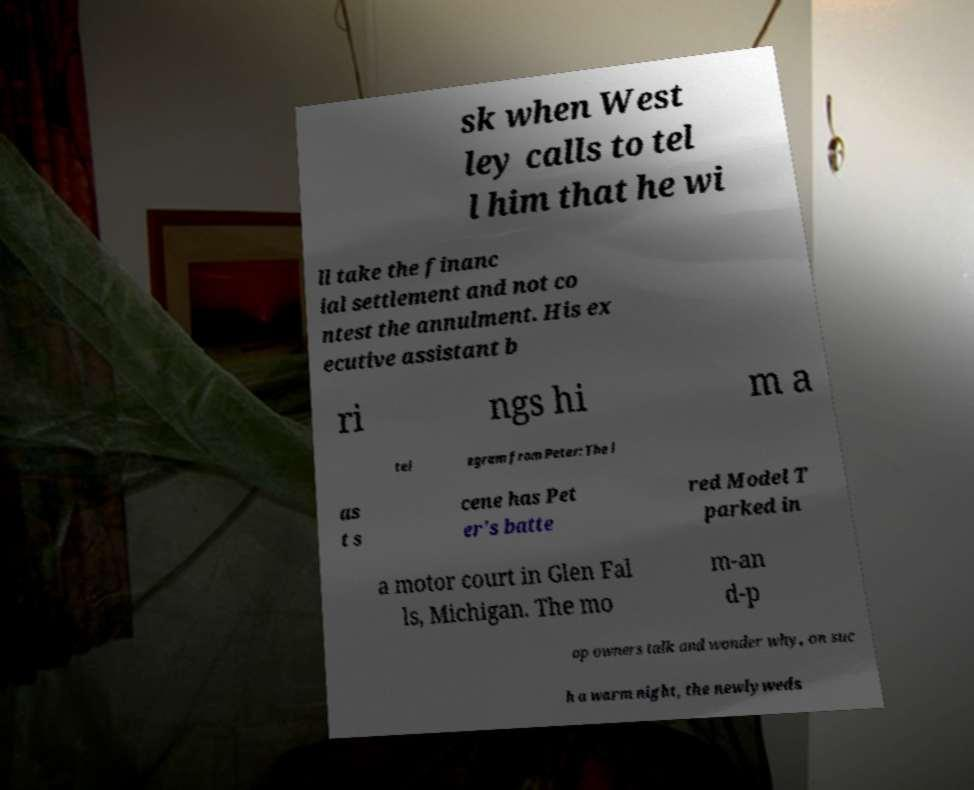Can you read and provide the text displayed in the image?This photo seems to have some interesting text. Can you extract and type it out for me? sk when West ley calls to tel l him that he wi ll take the financ ial settlement and not co ntest the annulment. His ex ecutive assistant b ri ngs hi m a tel egram from Peter: The l as t s cene has Pet er's batte red Model T parked in a motor court in Glen Fal ls, Michigan. The mo m-an d-p op owners talk and wonder why, on suc h a warm night, the newlyweds 